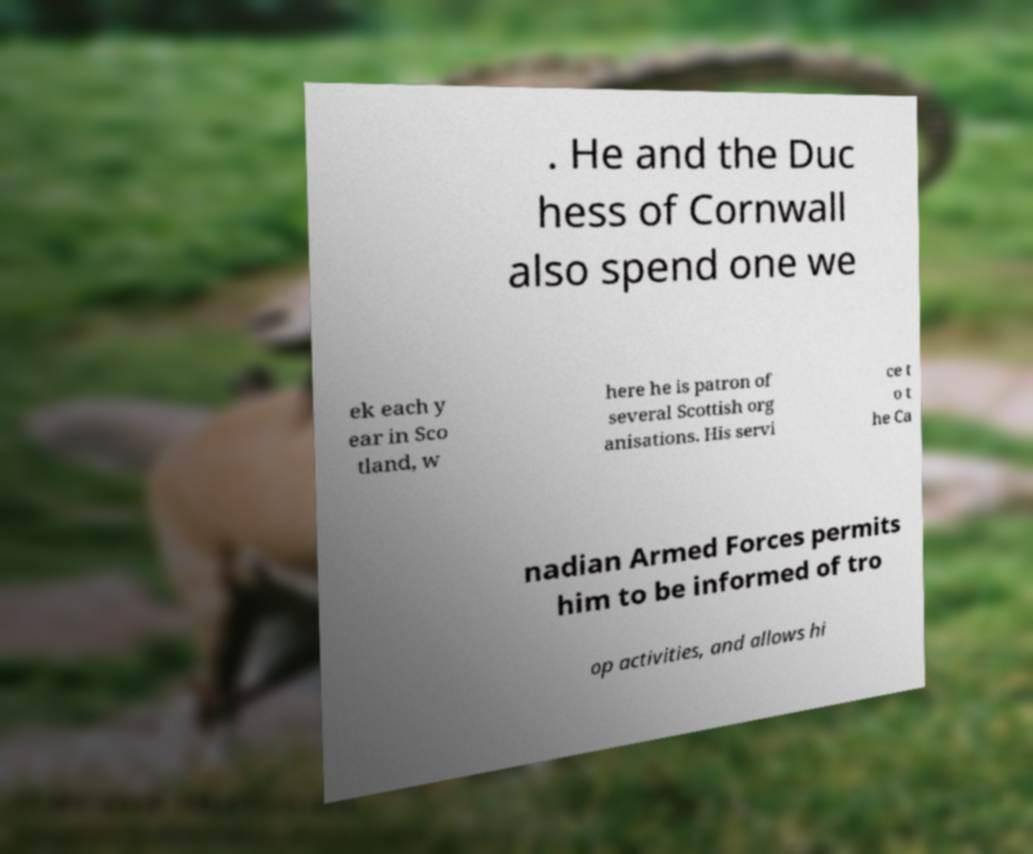Can you read and provide the text displayed in the image?This photo seems to have some interesting text. Can you extract and type it out for me? . He and the Duc hess of Cornwall also spend one we ek each y ear in Sco tland, w here he is patron of several Scottish org anisations. His servi ce t o t he Ca nadian Armed Forces permits him to be informed of tro op activities, and allows hi 